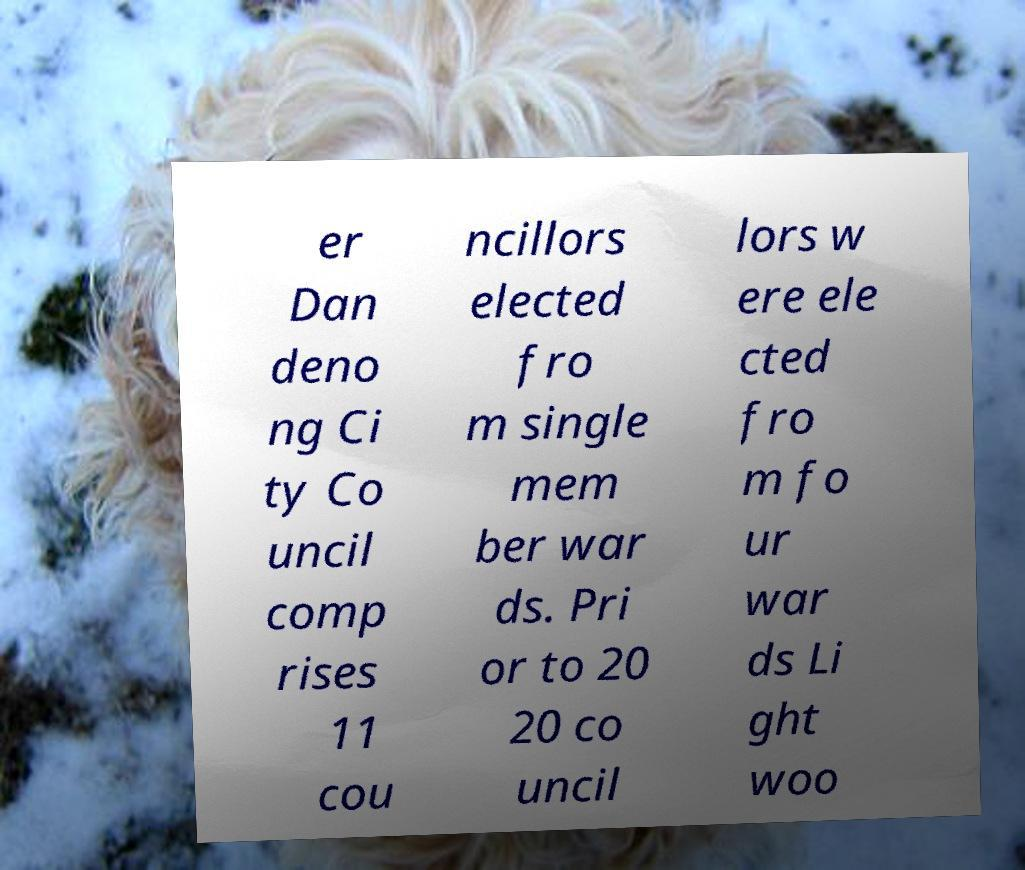Please read and relay the text visible in this image. What does it say? er Dan deno ng Ci ty Co uncil comp rises 11 cou ncillors elected fro m single mem ber war ds. Pri or to 20 20 co uncil lors w ere ele cted fro m fo ur war ds Li ght woo 